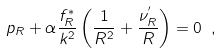<formula> <loc_0><loc_0><loc_500><loc_500>p _ { R } + \alpha \frac { f ^ { * } _ { R } } { k ^ { 2 } } \left ( \frac { 1 } { R ^ { 2 } } + \frac { \nu ^ { ^ { \prime } } _ { R } } { R } \right ) = 0 \ ,</formula> 